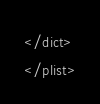Convert code to text. <code><loc_0><loc_0><loc_500><loc_500><_XML_></dict>
</plist>
</code> 